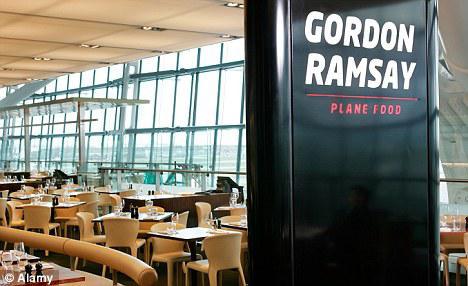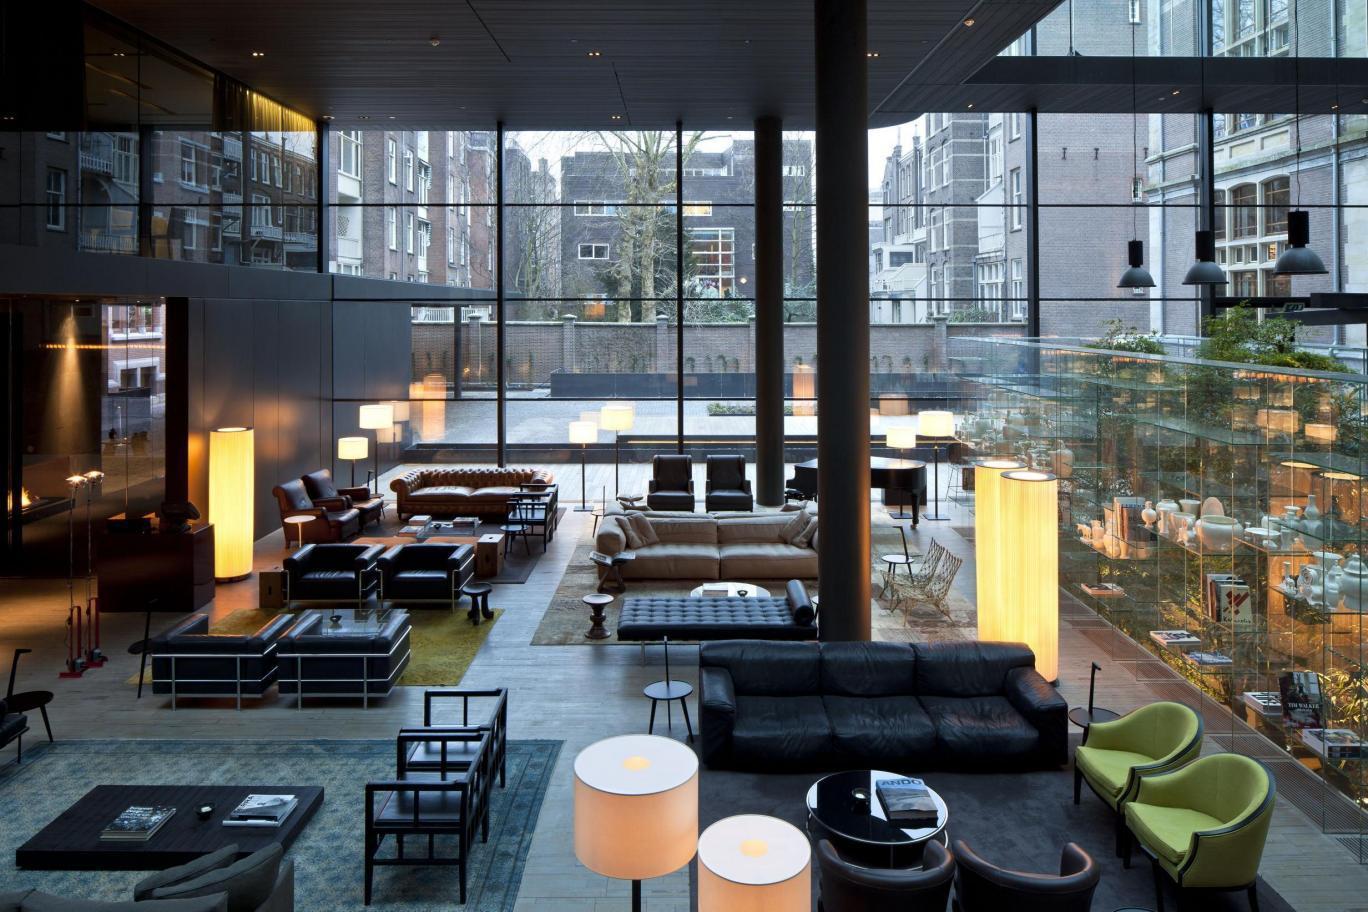The first image is the image on the left, the second image is the image on the right. For the images displayed, is the sentence "One of the restaurants has several customers sitting in chairs." factually correct? Answer yes or no. No. 